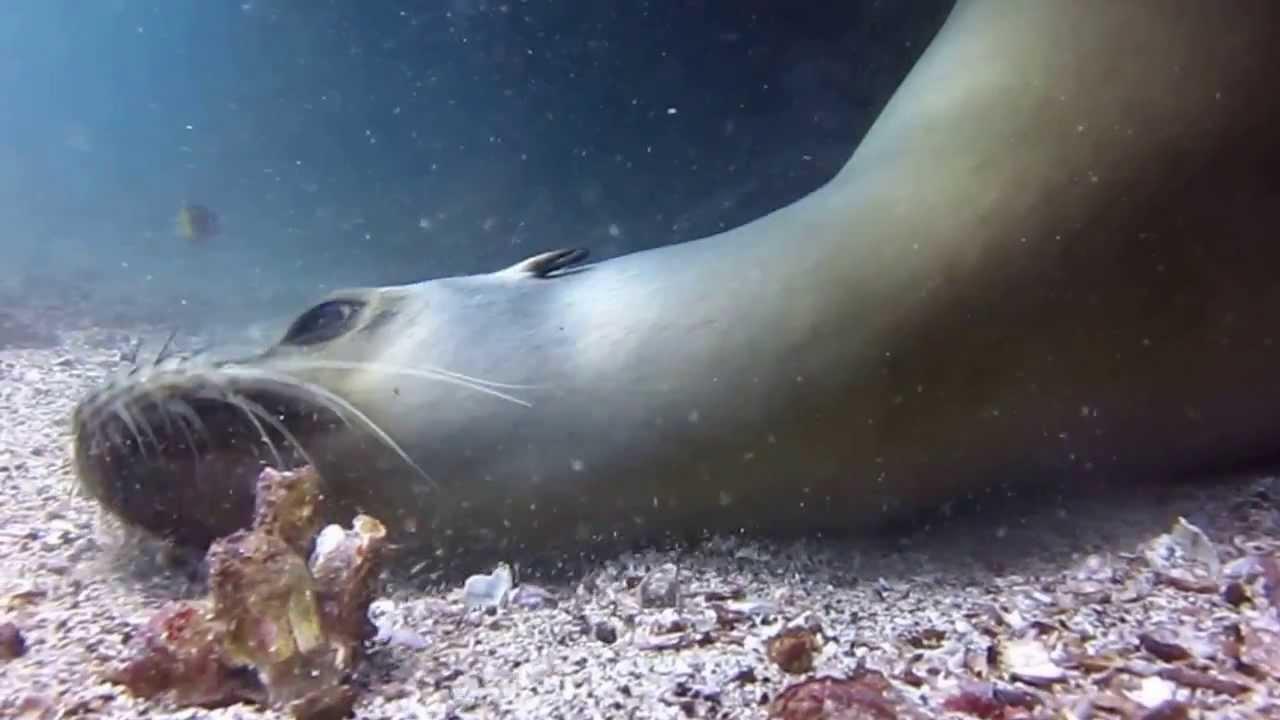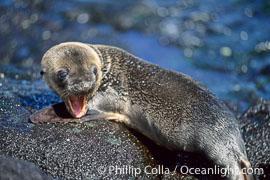The first image is the image on the left, the second image is the image on the right. For the images shown, is this caption "An image includes at least one human diver swimming in the vicinity of a seal." true? Answer yes or no. No. The first image is the image on the left, the second image is the image on the right. For the images displayed, is the sentence "A person is swimming with the animals in the image on the left." factually correct? Answer yes or no. No. 